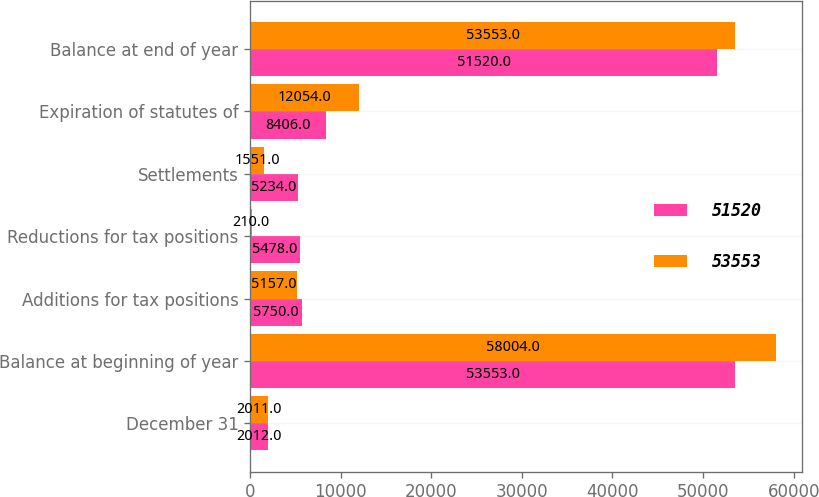Convert chart to OTSL. <chart><loc_0><loc_0><loc_500><loc_500><stacked_bar_chart><ecel><fcel>December 31<fcel>Balance at beginning of year<fcel>Additions for tax positions<fcel>Reductions for tax positions<fcel>Settlements<fcel>Expiration of statutes of<fcel>Balance at end of year<nl><fcel>51520<fcel>2012<fcel>53553<fcel>5750<fcel>5478<fcel>5234<fcel>8406<fcel>51520<nl><fcel>53553<fcel>2011<fcel>58004<fcel>5157<fcel>210<fcel>1551<fcel>12054<fcel>53553<nl></chart> 